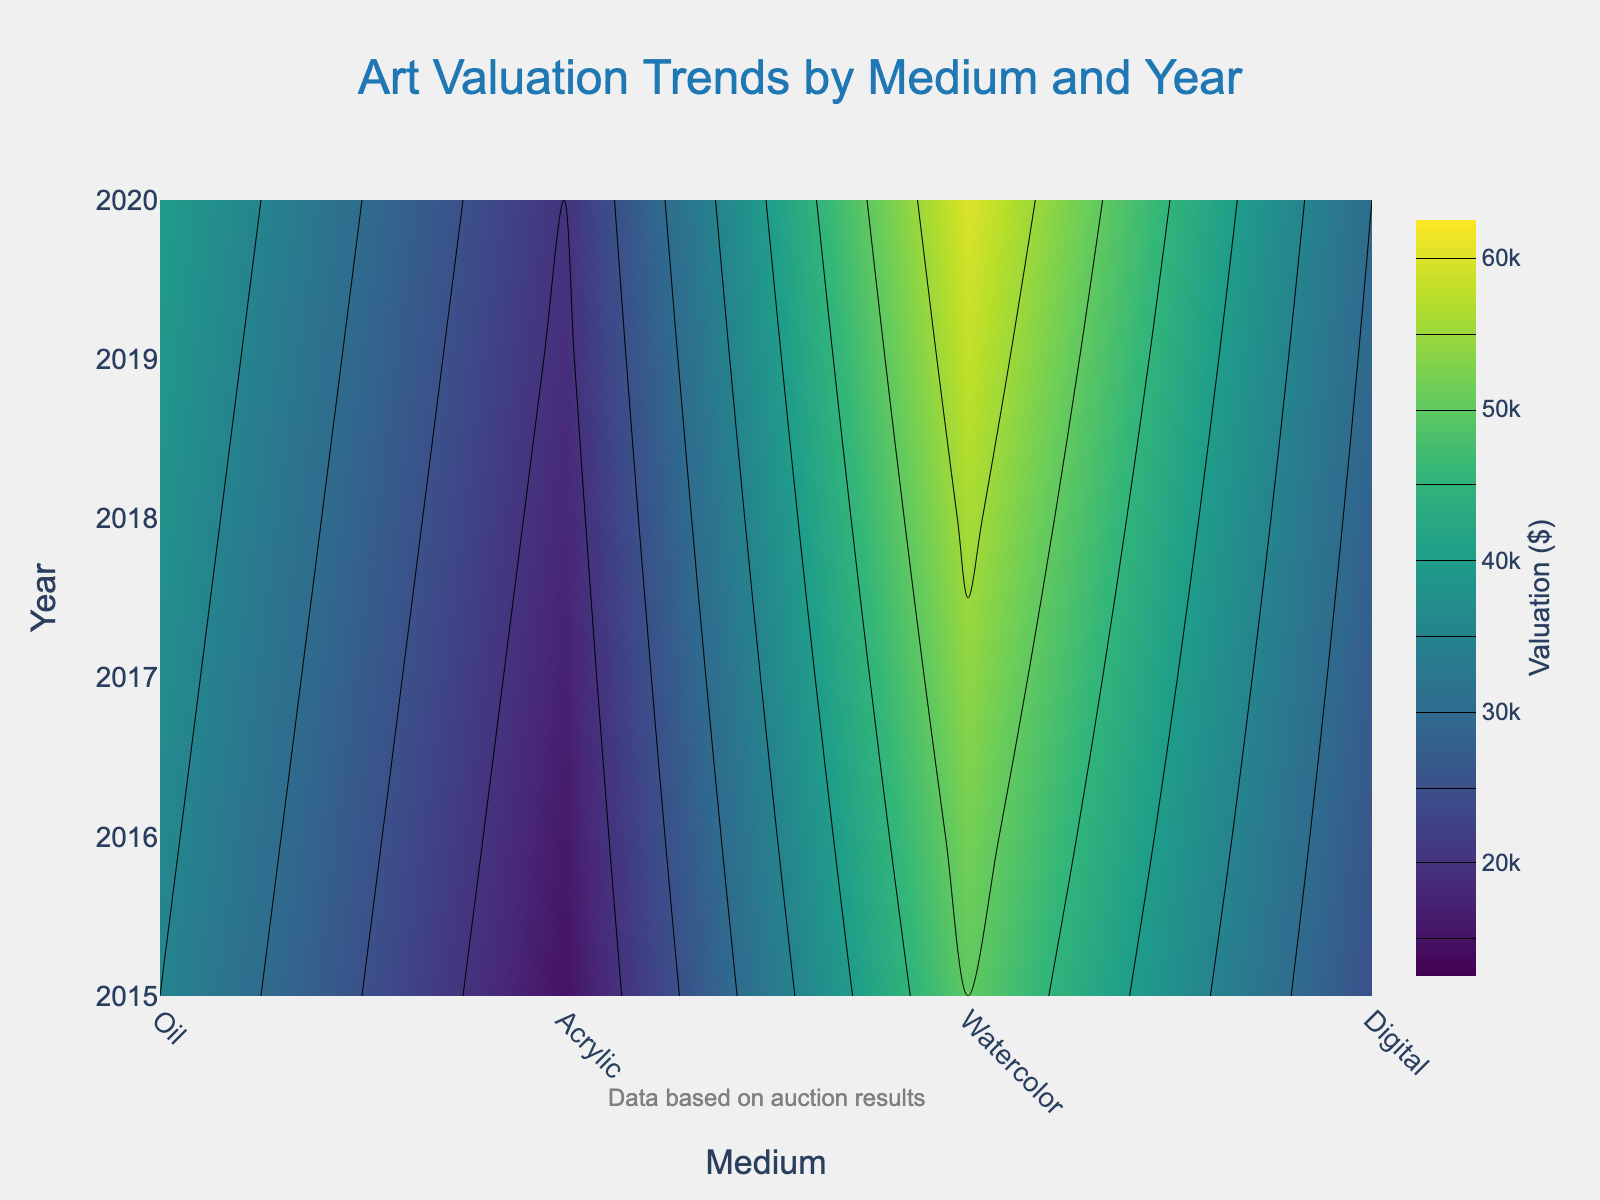What is the title of the plot? The title is usually prominently displayed at the top of the plot. By looking at the plot, it's clear that the title refers to the trends of art valuations.
Answer: Art Valuation Trends by Medium and Year Which medium had the highest average valuation in 2020? By observing 2020 on the y-axis and looking across the different medium categories on the x-axis, the contour plot shows the highest valuation level marked for the 'Oil' medium.
Answer: Oil How does the average valuation of Digital art compare from 2015 to 2020? Find Digital on the x-axis and then compare the contour levels from 2015 to 2020 on the y-axis. Digital art valuations show a consistent increase from $15000 to $20000.
Answer: Increased by $5000 What is the range of average valuations for Acrylic artworks in 2017? On the contour plot, locate 2017 on the y-axis and find the Acrylic medium on the x-axis. The contours indicate valuation levels. In 2017, Acrylic art had valuations between $35000 and $40000.
Answer: $35000 to $40000 Between 2016 and 2019, which year shows the most significant increase in the valuation of Watercolor art? By tracking the contour levels for Watercolor on the y-axis from 2016 through 2019, it's clear that the maximum valuation change occurs between the years with the steepest contour gradient. The largest increase is from 2016 to 2017.
Answer: 2016 to 2017 What can we say about the trend for Oil artworks' valuations from 2015 to 2020? Observe the contour lines for the Oil medium from 2015 to 2020. There is a consistent trend upward, indicating a steady increase in valuations over time.
Answer: Steadily increasing Which medium shows the least fluctuation in average valuation from 2015 to 2020? By comparing the contour plots for each medium, the medium with the least contour line variation over the years will have the least fluctuations. Digital, with minimal changes in its contours, shows the least fluctuation.
Answer: Digital How much did the valuation for Acrylic artworks increase from 2018 to 2020? Locate 2018 and 2020 for Acrylic on the contour plot and note the valuation levels. Acrylic increased from $38000 in 2018 to $40000 in 2020. Subtracting these gives us the increase amount.
Answer: $2000 What themes can we derive from the overall color gradient of the plot from 2015 to 2020? Examining the color gradient transition in the plot from 2015 to 2020 shows that the rightmost side (likely Oil) trends towards higher valuation shades, while the leftmost side (likely Digital) maintains the lowest valuation shades. This indicates greater valuation increases in certain mediums than others.
Answer: Higher valuation increases for traditional mediums like Oil, while Digital remains lower 